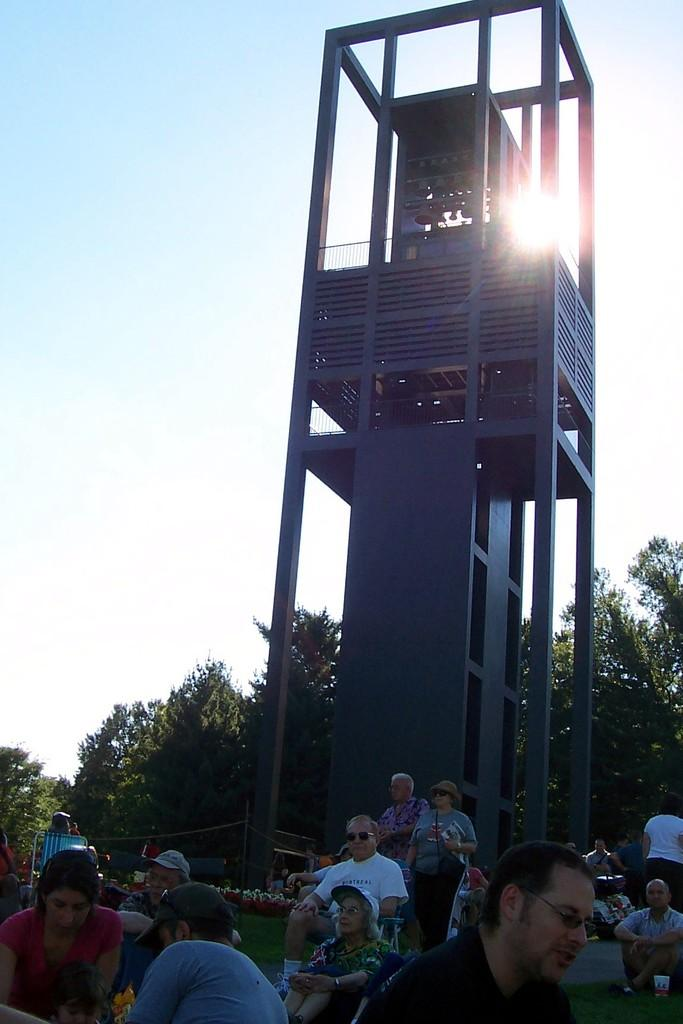What is the main subject in the foreground of the image? There is a carillon in the foreground of the image. What are the people in the image doing? There are persons sitting on the grass in front of the carillon. What can be seen in the background of the image? There are trees and the sky visible in the background of the image. Can the sun be seen in the image? Yes, the sun is observable in the sky. What type of receipt can be seen in the image? There is no receipt present in the image. What position are the persons sitting in front of the carillon? The provided facts do not specify the exact position of the persons sitting on the grass, so we cannot answer this question definitively. 